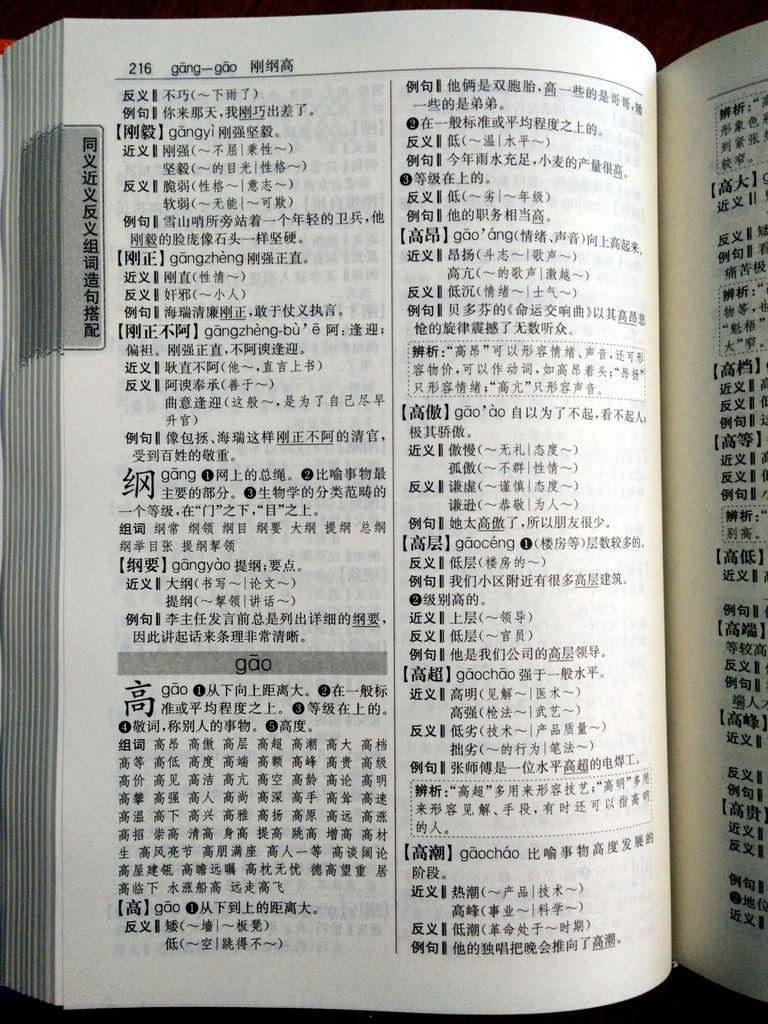<image>
Share a concise interpretation of the image provided. A book in an Asian language is opened to page 216 with the heading "gang-gao." 